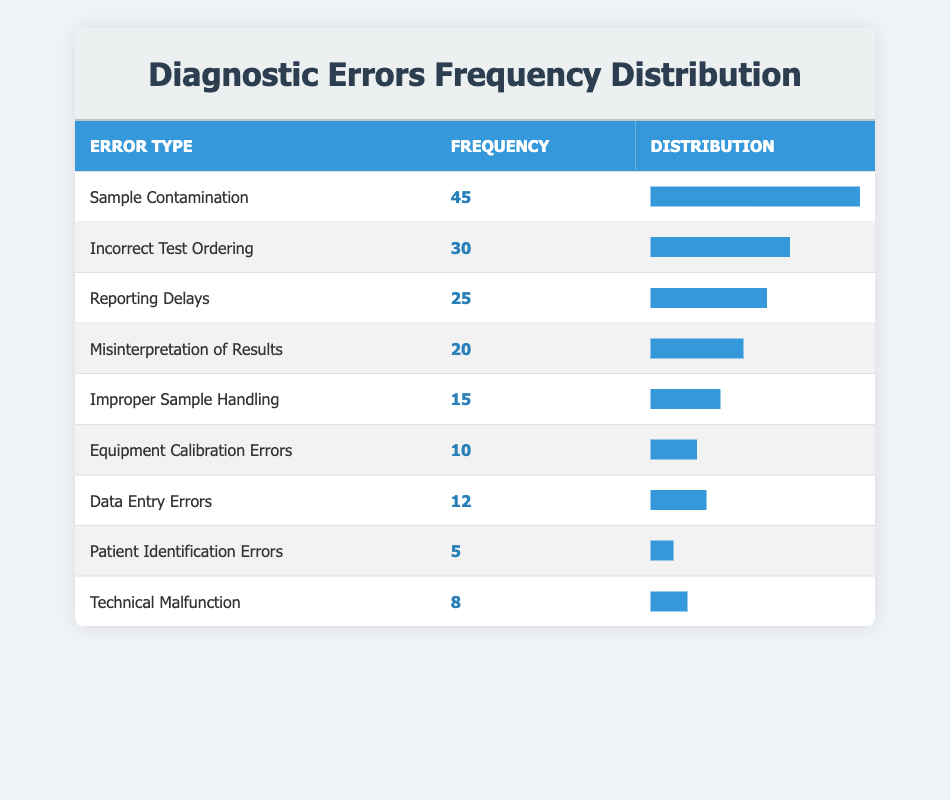What is the most common type of diagnostic error reported? The most common type of diagnostic error is identified by looking for the highest frequency value in the table, which is 45 for Sample Contamination.
Answer: Sample Contamination How many diagnostic errors were associated with Incorrect Test Ordering? The frequency for Incorrect Test Ordering is listed directly in the table as 30.
Answer: 30 What is the total frequency of Reporting Delays and Misinterpretation of Results? To find the total frequency, we need to sum the frequencies of Reporting Delays (25) and Misinterpretation of Results (20), which gives us 25 + 20 = 45.
Answer: 45 Is the frequency of Patient Identification Errors greater than the frequency of Technical Malfunction? The frequency of Patient Identification Errors is 5, while the frequency for Technical Malfunction is 8. Since 5 is not greater than 8, the answer is no.
Answer: No What is the average frequency of the 9 types of diagnostic errors mentioned in the table? To calculate the average, we first sum the frequencies of all diagnostic errors: 45 + 30 + 25 + 20 + 15 + 10 + 12 + 5 + 8 =  175. There are 9 categories, so we divide by 9: 175 / 9 ≈ 19.44.
Answer: 19.44 Which diagnostic error has the least frequency, and what is that frequency? By examining the frequency values, Patient Identification Errors has the least frequency, which is 5.
Answer: Patient Identification Errors, 5 How many more errors were there for Sample Contamination than Equipment Calibration Errors? The frequency for Sample Contamination is 45, while for Equipment Calibration Errors it is 10. We find the difference by calculating 45 - 10 = 35.
Answer: 35 Does the combined frequency of Equipment Calibration Errors and Data Entry Errors exceed that of Reporting Delays? The combined frequency for Equipment Calibration Errors (10) and Data Entry Errors (12) is 10 + 12 = 22. Reporting Delays has a frequency of 25. Since 22 is less than 25, the answer is no.
Answer: No 